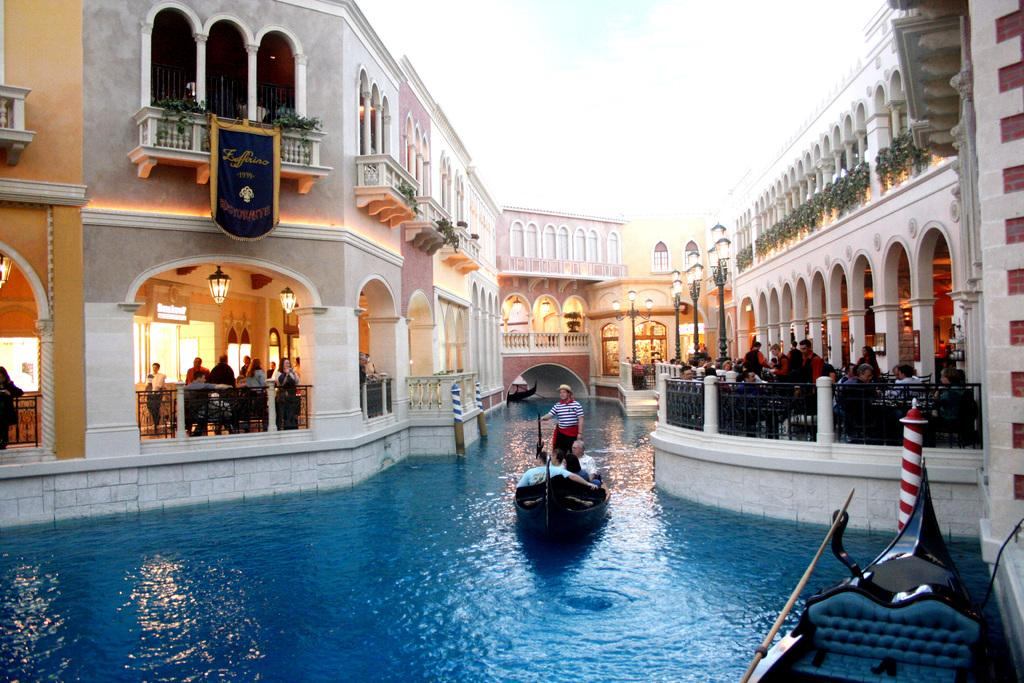What type of structures can be seen in the image? There are buildings in the image. What body of water is present at the bottom of the image? There is a canal at the bottom of the image. What is on the canal in the image? Boats are present on the canal. Are there any people in the boats? Yes, there are people in the boats. What can be seen in the background of the image? The sky is visible in the background of the image. Can you see any quince being sold in the lunchroom in the image? There is no lunchroom or quince present in the image. Are there any ants visible on the boats in the image? There are no ants visible in the image. 